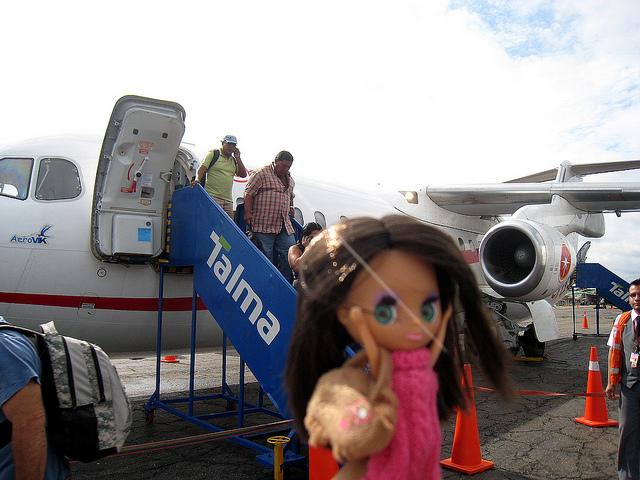How many full cones are viewable?
Keep it brief. 3. Is this a real doll?
Keep it brief. Yes. Are any people getting off the airplane?
Answer briefly. Yes. 